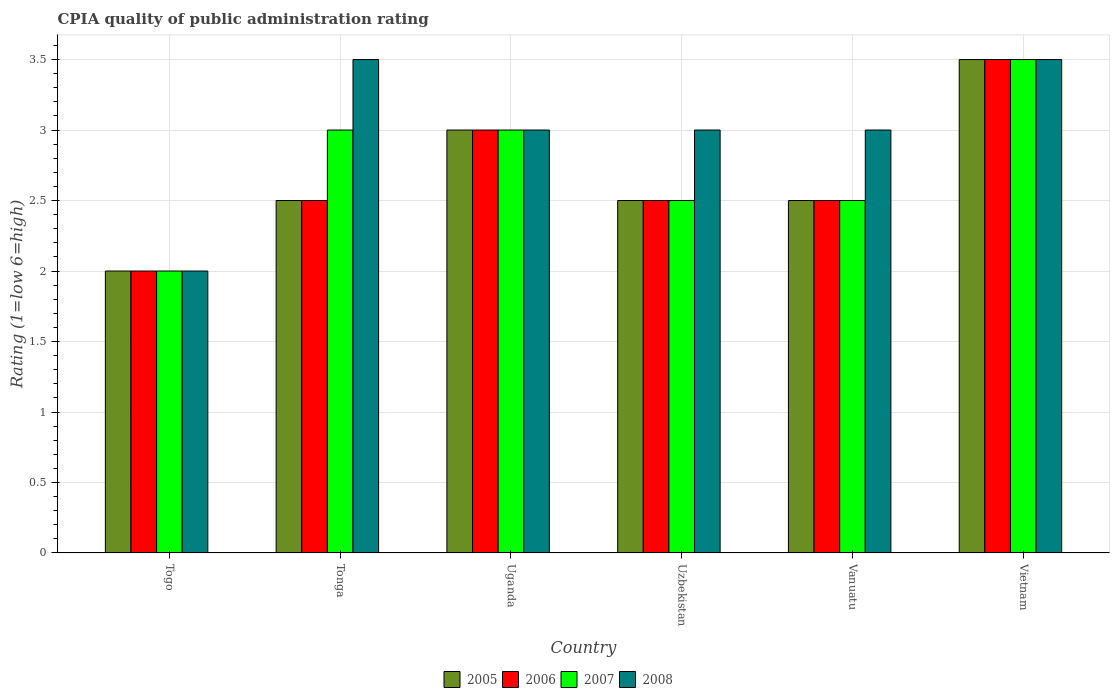How many different coloured bars are there?
Give a very brief answer. 4. Are the number of bars per tick equal to the number of legend labels?
Provide a short and direct response. Yes. How many bars are there on the 2nd tick from the right?
Ensure brevity in your answer.  4. What is the label of the 2nd group of bars from the left?
Offer a terse response. Tonga. In how many cases, is the number of bars for a given country not equal to the number of legend labels?
Make the answer very short. 0. What is the CPIA rating in 2008 in Vietnam?
Your answer should be very brief. 3.5. Across all countries, what is the maximum CPIA rating in 2005?
Your answer should be compact. 3.5. In which country was the CPIA rating in 2006 maximum?
Your answer should be very brief. Vietnam. In which country was the CPIA rating in 2006 minimum?
Your answer should be very brief. Togo. What is the difference between the CPIA rating in 2006 in Togo and that in Uzbekistan?
Provide a short and direct response. -0.5. What is the average CPIA rating in 2006 per country?
Your answer should be compact. 2.67. In how many countries, is the CPIA rating in 2006 greater than 1.8?
Provide a succinct answer. 6. What is the ratio of the CPIA rating in 2005 in Uzbekistan to that in Vanuatu?
Your answer should be compact. 1. Is the difference between the CPIA rating in 2007 in Uganda and Vanuatu greater than the difference between the CPIA rating in 2006 in Uganda and Vanuatu?
Make the answer very short. No. What is the difference between the highest and the lowest CPIA rating in 2007?
Offer a very short reply. 1.5. Is the sum of the CPIA rating in 2007 in Uganda and Uzbekistan greater than the maximum CPIA rating in 2006 across all countries?
Your answer should be very brief. Yes. Is it the case that in every country, the sum of the CPIA rating in 2008 and CPIA rating in 2007 is greater than the sum of CPIA rating in 2006 and CPIA rating in 2005?
Offer a very short reply. No. What does the 4th bar from the right in Vanuatu represents?
Your answer should be compact. 2005. Is it the case that in every country, the sum of the CPIA rating in 2008 and CPIA rating in 2007 is greater than the CPIA rating in 2006?
Provide a succinct answer. Yes. How many countries are there in the graph?
Offer a terse response. 6. Where does the legend appear in the graph?
Offer a very short reply. Bottom center. How many legend labels are there?
Provide a succinct answer. 4. How are the legend labels stacked?
Your answer should be compact. Horizontal. What is the title of the graph?
Your answer should be very brief. CPIA quality of public administration rating. What is the Rating (1=low 6=high) of 2006 in Togo?
Your answer should be very brief. 2. What is the Rating (1=low 6=high) in 2007 in Togo?
Your response must be concise. 2. What is the Rating (1=low 6=high) in 2005 in Tonga?
Give a very brief answer. 2.5. What is the Rating (1=low 6=high) of 2008 in Tonga?
Make the answer very short. 3.5. What is the Rating (1=low 6=high) in 2007 in Uganda?
Make the answer very short. 3. What is the Rating (1=low 6=high) of 2008 in Uganda?
Your response must be concise. 3. What is the Rating (1=low 6=high) of 2005 in Uzbekistan?
Provide a succinct answer. 2.5. What is the Rating (1=low 6=high) in 2006 in Uzbekistan?
Make the answer very short. 2.5. What is the Rating (1=low 6=high) in 2007 in Uzbekistan?
Ensure brevity in your answer.  2.5. What is the Rating (1=low 6=high) of 2008 in Uzbekistan?
Your answer should be very brief. 3. What is the Rating (1=low 6=high) of 2008 in Vanuatu?
Ensure brevity in your answer.  3. What is the Rating (1=low 6=high) of 2007 in Vietnam?
Offer a very short reply. 3.5. What is the Rating (1=low 6=high) in 2008 in Vietnam?
Keep it short and to the point. 3.5. Across all countries, what is the maximum Rating (1=low 6=high) of 2005?
Keep it short and to the point. 3.5. Across all countries, what is the maximum Rating (1=low 6=high) of 2008?
Offer a very short reply. 3.5. Across all countries, what is the minimum Rating (1=low 6=high) of 2005?
Your answer should be compact. 2. Across all countries, what is the minimum Rating (1=low 6=high) of 2008?
Give a very brief answer. 2. What is the total Rating (1=low 6=high) of 2006 in the graph?
Keep it short and to the point. 16. What is the total Rating (1=low 6=high) of 2008 in the graph?
Your answer should be compact. 18. What is the difference between the Rating (1=low 6=high) in 2006 in Togo and that in Tonga?
Your answer should be very brief. -0.5. What is the difference between the Rating (1=low 6=high) in 2007 in Togo and that in Tonga?
Provide a short and direct response. -1. What is the difference between the Rating (1=low 6=high) in 2005 in Togo and that in Uganda?
Keep it short and to the point. -1. What is the difference between the Rating (1=low 6=high) in 2006 in Togo and that in Uganda?
Your answer should be very brief. -1. What is the difference between the Rating (1=low 6=high) in 2007 in Togo and that in Uganda?
Make the answer very short. -1. What is the difference between the Rating (1=low 6=high) in 2006 in Togo and that in Uzbekistan?
Your answer should be compact. -0.5. What is the difference between the Rating (1=low 6=high) of 2008 in Togo and that in Uzbekistan?
Offer a terse response. -1. What is the difference between the Rating (1=low 6=high) in 2006 in Togo and that in Vanuatu?
Ensure brevity in your answer.  -0.5. What is the difference between the Rating (1=low 6=high) of 2007 in Togo and that in Vanuatu?
Your answer should be very brief. -0.5. What is the difference between the Rating (1=low 6=high) in 2007 in Togo and that in Vietnam?
Your answer should be very brief. -1.5. What is the difference between the Rating (1=low 6=high) in 2006 in Tonga and that in Uganda?
Keep it short and to the point. -0.5. What is the difference between the Rating (1=low 6=high) in 2007 in Tonga and that in Uganda?
Offer a terse response. 0. What is the difference between the Rating (1=low 6=high) in 2008 in Tonga and that in Uganda?
Ensure brevity in your answer.  0.5. What is the difference between the Rating (1=low 6=high) in 2005 in Tonga and that in Uzbekistan?
Give a very brief answer. 0. What is the difference between the Rating (1=low 6=high) of 2008 in Tonga and that in Uzbekistan?
Offer a terse response. 0.5. What is the difference between the Rating (1=low 6=high) of 2006 in Tonga and that in Vanuatu?
Keep it short and to the point. 0. What is the difference between the Rating (1=low 6=high) in 2007 in Tonga and that in Vanuatu?
Provide a succinct answer. 0.5. What is the difference between the Rating (1=low 6=high) in 2008 in Tonga and that in Vanuatu?
Offer a terse response. 0.5. What is the difference between the Rating (1=low 6=high) of 2005 in Tonga and that in Vietnam?
Provide a succinct answer. -1. What is the difference between the Rating (1=low 6=high) of 2008 in Tonga and that in Vietnam?
Your response must be concise. 0. What is the difference between the Rating (1=low 6=high) in 2006 in Uganda and that in Uzbekistan?
Ensure brevity in your answer.  0.5. What is the difference between the Rating (1=low 6=high) in 2006 in Uganda and that in Vanuatu?
Ensure brevity in your answer.  0.5. What is the difference between the Rating (1=low 6=high) in 2007 in Uganda and that in Vietnam?
Your answer should be compact. -0.5. What is the difference between the Rating (1=low 6=high) in 2008 in Uganda and that in Vietnam?
Ensure brevity in your answer.  -0.5. What is the difference between the Rating (1=low 6=high) of 2005 in Uzbekistan and that in Vanuatu?
Give a very brief answer. 0. What is the difference between the Rating (1=low 6=high) of 2007 in Uzbekistan and that in Vanuatu?
Your response must be concise. 0. What is the difference between the Rating (1=low 6=high) in 2008 in Uzbekistan and that in Vietnam?
Give a very brief answer. -0.5. What is the difference between the Rating (1=low 6=high) of 2005 in Vanuatu and that in Vietnam?
Your answer should be very brief. -1. What is the difference between the Rating (1=low 6=high) of 2008 in Vanuatu and that in Vietnam?
Ensure brevity in your answer.  -0.5. What is the difference between the Rating (1=low 6=high) of 2005 in Togo and the Rating (1=low 6=high) of 2008 in Tonga?
Your answer should be compact. -1.5. What is the difference between the Rating (1=low 6=high) of 2006 in Togo and the Rating (1=low 6=high) of 2008 in Tonga?
Keep it short and to the point. -1.5. What is the difference between the Rating (1=low 6=high) of 2007 in Togo and the Rating (1=low 6=high) of 2008 in Tonga?
Offer a terse response. -1.5. What is the difference between the Rating (1=low 6=high) in 2005 in Togo and the Rating (1=low 6=high) in 2006 in Uganda?
Make the answer very short. -1. What is the difference between the Rating (1=low 6=high) of 2005 in Togo and the Rating (1=low 6=high) of 2008 in Uganda?
Provide a short and direct response. -1. What is the difference between the Rating (1=low 6=high) in 2006 in Togo and the Rating (1=low 6=high) in 2007 in Uganda?
Offer a terse response. -1. What is the difference between the Rating (1=low 6=high) in 2006 in Togo and the Rating (1=low 6=high) in 2008 in Uganda?
Offer a terse response. -1. What is the difference between the Rating (1=low 6=high) in 2005 in Togo and the Rating (1=low 6=high) in 2007 in Uzbekistan?
Your answer should be very brief. -0.5. What is the difference between the Rating (1=low 6=high) of 2005 in Togo and the Rating (1=low 6=high) of 2008 in Uzbekistan?
Keep it short and to the point. -1. What is the difference between the Rating (1=low 6=high) of 2006 in Togo and the Rating (1=low 6=high) of 2008 in Uzbekistan?
Ensure brevity in your answer.  -1. What is the difference between the Rating (1=low 6=high) in 2005 in Togo and the Rating (1=low 6=high) in 2006 in Vanuatu?
Make the answer very short. -0.5. What is the difference between the Rating (1=low 6=high) of 2005 in Togo and the Rating (1=low 6=high) of 2007 in Vanuatu?
Provide a short and direct response. -0.5. What is the difference between the Rating (1=low 6=high) in 2005 in Togo and the Rating (1=low 6=high) in 2008 in Vanuatu?
Offer a terse response. -1. What is the difference between the Rating (1=low 6=high) in 2007 in Togo and the Rating (1=low 6=high) in 2008 in Vanuatu?
Give a very brief answer. -1. What is the difference between the Rating (1=low 6=high) in 2005 in Togo and the Rating (1=low 6=high) in 2006 in Vietnam?
Ensure brevity in your answer.  -1.5. What is the difference between the Rating (1=low 6=high) of 2005 in Togo and the Rating (1=low 6=high) of 2007 in Vietnam?
Keep it short and to the point. -1.5. What is the difference between the Rating (1=low 6=high) of 2005 in Togo and the Rating (1=low 6=high) of 2008 in Vietnam?
Offer a very short reply. -1.5. What is the difference between the Rating (1=low 6=high) in 2006 in Togo and the Rating (1=low 6=high) in 2007 in Vietnam?
Your answer should be compact. -1.5. What is the difference between the Rating (1=low 6=high) of 2007 in Togo and the Rating (1=low 6=high) of 2008 in Vietnam?
Your answer should be very brief. -1.5. What is the difference between the Rating (1=low 6=high) in 2005 in Tonga and the Rating (1=low 6=high) in 2007 in Uganda?
Provide a short and direct response. -0.5. What is the difference between the Rating (1=low 6=high) in 2006 in Tonga and the Rating (1=low 6=high) in 2008 in Uganda?
Keep it short and to the point. -0.5. What is the difference between the Rating (1=low 6=high) in 2005 in Tonga and the Rating (1=low 6=high) in 2008 in Uzbekistan?
Ensure brevity in your answer.  -0.5. What is the difference between the Rating (1=low 6=high) of 2006 in Tonga and the Rating (1=low 6=high) of 2008 in Uzbekistan?
Your response must be concise. -0.5. What is the difference between the Rating (1=low 6=high) in 2005 in Tonga and the Rating (1=low 6=high) in 2008 in Vanuatu?
Your response must be concise. -0.5. What is the difference between the Rating (1=low 6=high) of 2006 in Tonga and the Rating (1=low 6=high) of 2007 in Vanuatu?
Offer a very short reply. 0. What is the difference between the Rating (1=low 6=high) of 2006 in Tonga and the Rating (1=low 6=high) of 2008 in Vanuatu?
Ensure brevity in your answer.  -0.5. What is the difference between the Rating (1=low 6=high) in 2005 in Tonga and the Rating (1=low 6=high) in 2007 in Vietnam?
Your answer should be compact. -1. What is the difference between the Rating (1=low 6=high) of 2006 in Tonga and the Rating (1=low 6=high) of 2008 in Vietnam?
Provide a succinct answer. -1. What is the difference between the Rating (1=low 6=high) of 2007 in Tonga and the Rating (1=low 6=high) of 2008 in Vietnam?
Provide a short and direct response. -0.5. What is the difference between the Rating (1=low 6=high) in 2005 in Uganda and the Rating (1=low 6=high) in 2006 in Vanuatu?
Offer a very short reply. 0.5. What is the difference between the Rating (1=low 6=high) in 2005 in Uganda and the Rating (1=low 6=high) in 2007 in Vanuatu?
Keep it short and to the point. 0.5. What is the difference between the Rating (1=low 6=high) in 2005 in Uganda and the Rating (1=low 6=high) in 2008 in Vanuatu?
Provide a short and direct response. 0. What is the difference between the Rating (1=low 6=high) in 2006 in Uganda and the Rating (1=low 6=high) in 2007 in Vanuatu?
Offer a terse response. 0.5. What is the difference between the Rating (1=low 6=high) in 2007 in Uganda and the Rating (1=low 6=high) in 2008 in Vanuatu?
Your response must be concise. 0. What is the difference between the Rating (1=low 6=high) in 2005 in Uganda and the Rating (1=low 6=high) in 2006 in Vietnam?
Offer a terse response. -0.5. What is the difference between the Rating (1=low 6=high) of 2005 in Uganda and the Rating (1=low 6=high) of 2008 in Vietnam?
Ensure brevity in your answer.  -0.5. What is the difference between the Rating (1=low 6=high) in 2006 in Uganda and the Rating (1=low 6=high) in 2007 in Vietnam?
Your answer should be very brief. -0.5. What is the difference between the Rating (1=low 6=high) in 2006 in Uganda and the Rating (1=low 6=high) in 2008 in Vietnam?
Provide a succinct answer. -0.5. What is the difference between the Rating (1=low 6=high) of 2005 in Uzbekistan and the Rating (1=low 6=high) of 2006 in Vanuatu?
Make the answer very short. 0. What is the difference between the Rating (1=low 6=high) in 2005 in Uzbekistan and the Rating (1=low 6=high) in 2007 in Vanuatu?
Provide a succinct answer. 0. What is the difference between the Rating (1=low 6=high) of 2006 in Uzbekistan and the Rating (1=low 6=high) of 2008 in Vanuatu?
Give a very brief answer. -0.5. What is the difference between the Rating (1=low 6=high) of 2007 in Uzbekistan and the Rating (1=low 6=high) of 2008 in Vanuatu?
Your answer should be compact. -0.5. What is the difference between the Rating (1=low 6=high) in 2005 in Uzbekistan and the Rating (1=low 6=high) in 2006 in Vietnam?
Your answer should be very brief. -1. What is the difference between the Rating (1=low 6=high) in 2005 in Uzbekistan and the Rating (1=low 6=high) in 2008 in Vietnam?
Your answer should be very brief. -1. What is the difference between the Rating (1=low 6=high) of 2006 in Uzbekistan and the Rating (1=low 6=high) of 2008 in Vietnam?
Your answer should be compact. -1. What is the difference between the Rating (1=low 6=high) of 2007 in Uzbekistan and the Rating (1=low 6=high) of 2008 in Vietnam?
Offer a terse response. -1. What is the difference between the Rating (1=low 6=high) in 2005 in Vanuatu and the Rating (1=low 6=high) in 2007 in Vietnam?
Your answer should be compact. -1. What is the difference between the Rating (1=low 6=high) of 2006 in Vanuatu and the Rating (1=low 6=high) of 2008 in Vietnam?
Keep it short and to the point. -1. What is the difference between the Rating (1=low 6=high) of 2007 in Vanuatu and the Rating (1=low 6=high) of 2008 in Vietnam?
Offer a very short reply. -1. What is the average Rating (1=low 6=high) in 2005 per country?
Offer a terse response. 2.67. What is the average Rating (1=low 6=high) of 2006 per country?
Ensure brevity in your answer.  2.67. What is the average Rating (1=low 6=high) of 2007 per country?
Provide a succinct answer. 2.75. What is the average Rating (1=low 6=high) of 2008 per country?
Ensure brevity in your answer.  3. What is the difference between the Rating (1=low 6=high) in 2005 and Rating (1=low 6=high) in 2007 in Togo?
Make the answer very short. 0. What is the difference between the Rating (1=low 6=high) in 2006 and Rating (1=low 6=high) in 2008 in Togo?
Your response must be concise. 0. What is the difference between the Rating (1=low 6=high) in 2007 and Rating (1=low 6=high) in 2008 in Togo?
Ensure brevity in your answer.  0. What is the difference between the Rating (1=low 6=high) of 2005 and Rating (1=low 6=high) of 2008 in Tonga?
Make the answer very short. -1. What is the difference between the Rating (1=low 6=high) in 2006 and Rating (1=low 6=high) in 2007 in Tonga?
Your answer should be compact. -0.5. What is the difference between the Rating (1=low 6=high) in 2005 and Rating (1=low 6=high) in 2006 in Uganda?
Your answer should be very brief. 0. What is the difference between the Rating (1=low 6=high) in 2005 and Rating (1=low 6=high) in 2008 in Uganda?
Offer a terse response. 0. What is the difference between the Rating (1=low 6=high) of 2006 and Rating (1=low 6=high) of 2008 in Uganda?
Ensure brevity in your answer.  0. What is the difference between the Rating (1=low 6=high) of 2006 and Rating (1=low 6=high) of 2008 in Uzbekistan?
Provide a succinct answer. -0.5. What is the difference between the Rating (1=low 6=high) of 2005 and Rating (1=low 6=high) of 2007 in Vanuatu?
Give a very brief answer. 0. What is the difference between the Rating (1=low 6=high) in 2005 and Rating (1=low 6=high) in 2008 in Vanuatu?
Offer a very short reply. -0.5. What is the difference between the Rating (1=low 6=high) of 2006 and Rating (1=low 6=high) of 2007 in Vanuatu?
Provide a short and direct response. 0. What is the difference between the Rating (1=low 6=high) of 2007 and Rating (1=low 6=high) of 2008 in Vanuatu?
Make the answer very short. -0.5. What is the difference between the Rating (1=low 6=high) in 2005 and Rating (1=low 6=high) in 2006 in Vietnam?
Offer a very short reply. 0. What is the difference between the Rating (1=low 6=high) in 2005 and Rating (1=low 6=high) in 2007 in Vietnam?
Offer a very short reply. 0. What is the difference between the Rating (1=low 6=high) of 2006 and Rating (1=low 6=high) of 2007 in Vietnam?
Your response must be concise. 0. What is the difference between the Rating (1=low 6=high) of 2006 and Rating (1=low 6=high) of 2008 in Vietnam?
Your answer should be very brief. 0. What is the ratio of the Rating (1=low 6=high) in 2005 in Togo to that in Tonga?
Your response must be concise. 0.8. What is the ratio of the Rating (1=low 6=high) of 2008 in Togo to that in Tonga?
Make the answer very short. 0.57. What is the ratio of the Rating (1=low 6=high) in 2007 in Togo to that in Uganda?
Provide a short and direct response. 0.67. What is the ratio of the Rating (1=low 6=high) of 2008 in Togo to that in Uganda?
Provide a short and direct response. 0.67. What is the ratio of the Rating (1=low 6=high) in 2007 in Togo to that in Uzbekistan?
Provide a short and direct response. 0.8. What is the ratio of the Rating (1=low 6=high) of 2007 in Togo to that in Vanuatu?
Your answer should be very brief. 0.8. What is the ratio of the Rating (1=low 6=high) in 2008 in Togo to that in Vanuatu?
Provide a succinct answer. 0.67. What is the ratio of the Rating (1=low 6=high) in 2006 in Togo to that in Vietnam?
Ensure brevity in your answer.  0.57. What is the ratio of the Rating (1=low 6=high) of 2007 in Togo to that in Vietnam?
Provide a short and direct response. 0.57. What is the ratio of the Rating (1=low 6=high) of 2008 in Togo to that in Vietnam?
Give a very brief answer. 0.57. What is the ratio of the Rating (1=low 6=high) in 2006 in Tonga to that in Uganda?
Offer a terse response. 0.83. What is the ratio of the Rating (1=low 6=high) in 2007 in Tonga to that in Uganda?
Provide a short and direct response. 1. What is the ratio of the Rating (1=low 6=high) in 2006 in Tonga to that in Uzbekistan?
Ensure brevity in your answer.  1. What is the ratio of the Rating (1=low 6=high) in 2007 in Tonga to that in Uzbekistan?
Your answer should be very brief. 1.2. What is the ratio of the Rating (1=low 6=high) of 2008 in Tonga to that in Uzbekistan?
Give a very brief answer. 1.17. What is the ratio of the Rating (1=low 6=high) in 2007 in Tonga to that in Vietnam?
Ensure brevity in your answer.  0.86. What is the ratio of the Rating (1=low 6=high) of 2008 in Tonga to that in Vietnam?
Provide a succinct answer. 1. What is the ratio of the Rating (1=low 6=high) in 2005 in Uganda to that in Uzbekistan?
Your response must be concise. 1.2. What is the ratio of the Rating (1=low 6=high) in 2006 in Uganda to that in Uzbekistan?
Offer a very short reply. 1.2. What is the ratio of the Rating (1=low 6=high) of 2007 in Uganda to that in Vanuatu?
Provide a short and direct response. 1.2. What is the ratio of the Rating (1=low 6=high) in 2008 in Uganda to that in Vietnam?
Provide a short and direct response. 0.86. What is the ratio of the Rating (1=low 6=high) in 2005 in Uzbekistan to that in Vanuatu?
Provide a short and direct response. 1. What is the ratio of the Rating (1=low 6=high) of 2005 in Uzbekistan to that in Vietnam?
Your response must be concise. 0.71. What is the ratio of the Rating (1=low 6=high) of 2008 in Uzbekistan to that in Vietnam?
Make the answer very short. 0.86. What is the ratio of the Rating (1=low 6=high) of 2006 in Vanuatu to that in Vietnam?
Keep it short and to the point. 0.71. What is the ratio of the Rating (1=low 6=high) of 2007 in Vanuatu to that in Vietnam?
Give a very brief answer. 0.71. What is the difference between the highest and the second highest Rating (1=low 6=high) of 2005?
Keep it short and to the point. 0.5. What is the difference between the highest and the second highest Rating (1=low 6=high) in 2007?
Provide a short and direct response. 0.5. What is the difference between the highest and the second highest Rating (1=low 6=high) of 2008?
Your response must be concise. 0. What is the difference between the highest and the lowest Rating (1=low 6=high) of 2005?
Your answer should be very brief. 1.5. What is the difference between the highest and the lowest Rating (1=low 6=high) of 2006?
Provide a succinct answer. 1.5. 